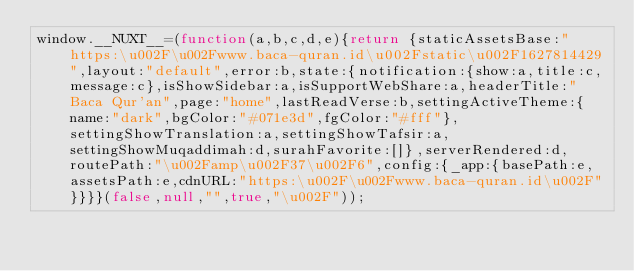<code> <loc_0><loc_0><loc_500><loc_500><_JavaScript_>window.__NUXT__=(function(a,b,c,d,e){return {staticAssetsBase:"https:\u002F\u002Fwww.baca-quran.id\u002Fstatic\u002F1627814429",layout:"default",error:b,state:{notification:{show:a,title:c,message:c},isShowSidebar:a,isSupportWebShare:a,headerTitle:"Baca Qur'an",page:"home",lastReadVerse:b,settingActiveTheme:{name:"dark",bgColor:"#071e3d",fgColor:"#fff"},settingShowTranslation:a,settingShowTafsir:a,settingShowMuqaddimah:d,surahFavorite:[]},serverRendered:d,routePath:"\u002Famp\u002F37\u002F6",config:{_app:{basePath:e,assetsPath:e,cdnURL:"https:\u002F\u002Fwww.baca-quran.id\u002F"}}}}(false,null,"",true,"\u002F"));</code> 